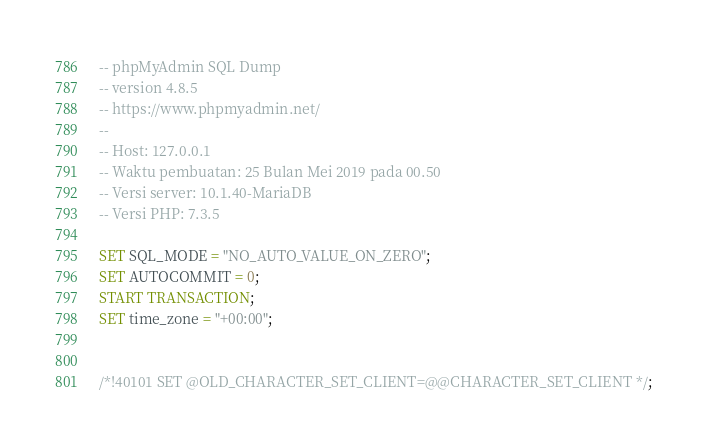<code> <loc_0><loc_0><loc_500><loc_500><_SQL_>-- phpMyAdmin SQL Dump
-- version 4.8.5
-- https://www.phpmyadmin.net/
--
-- Host: 127.0.0.1
-- Waktu pembuatan: 25 Bulan Mei 2019 pada 00.50
-- Versi server: 10.1.40-MariaDB
-- Versi PHP: 7.3.5

SET SQL_MODE = "NO_AUTO_VALUE_ON_ZERO";
SET AUTOCOMMIT = 0;
START TRANSACTION;
SET time_zone = "+00:00";


/*!40101 SET @OLD_CHARACTER_SET_CLIENT=@@CHARACTER_SET_CLIENT */;</code> 